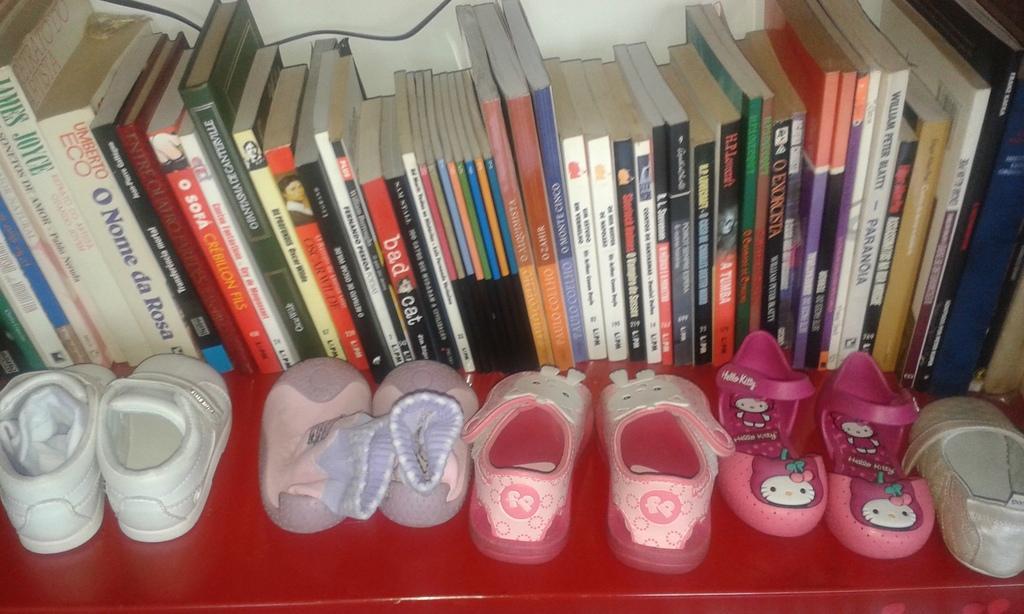In one or two sentences, can you explain what this image depicts? In this picture, there are books placed in a row at the top. At the bottom, there are shoes with different colors. 